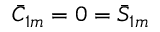<formula> <loc_0><loc_0><loc_500><loc_500>\bar { C } _ { 1 m } = 0 = \bar { S } _ { 1 m }</formula> 